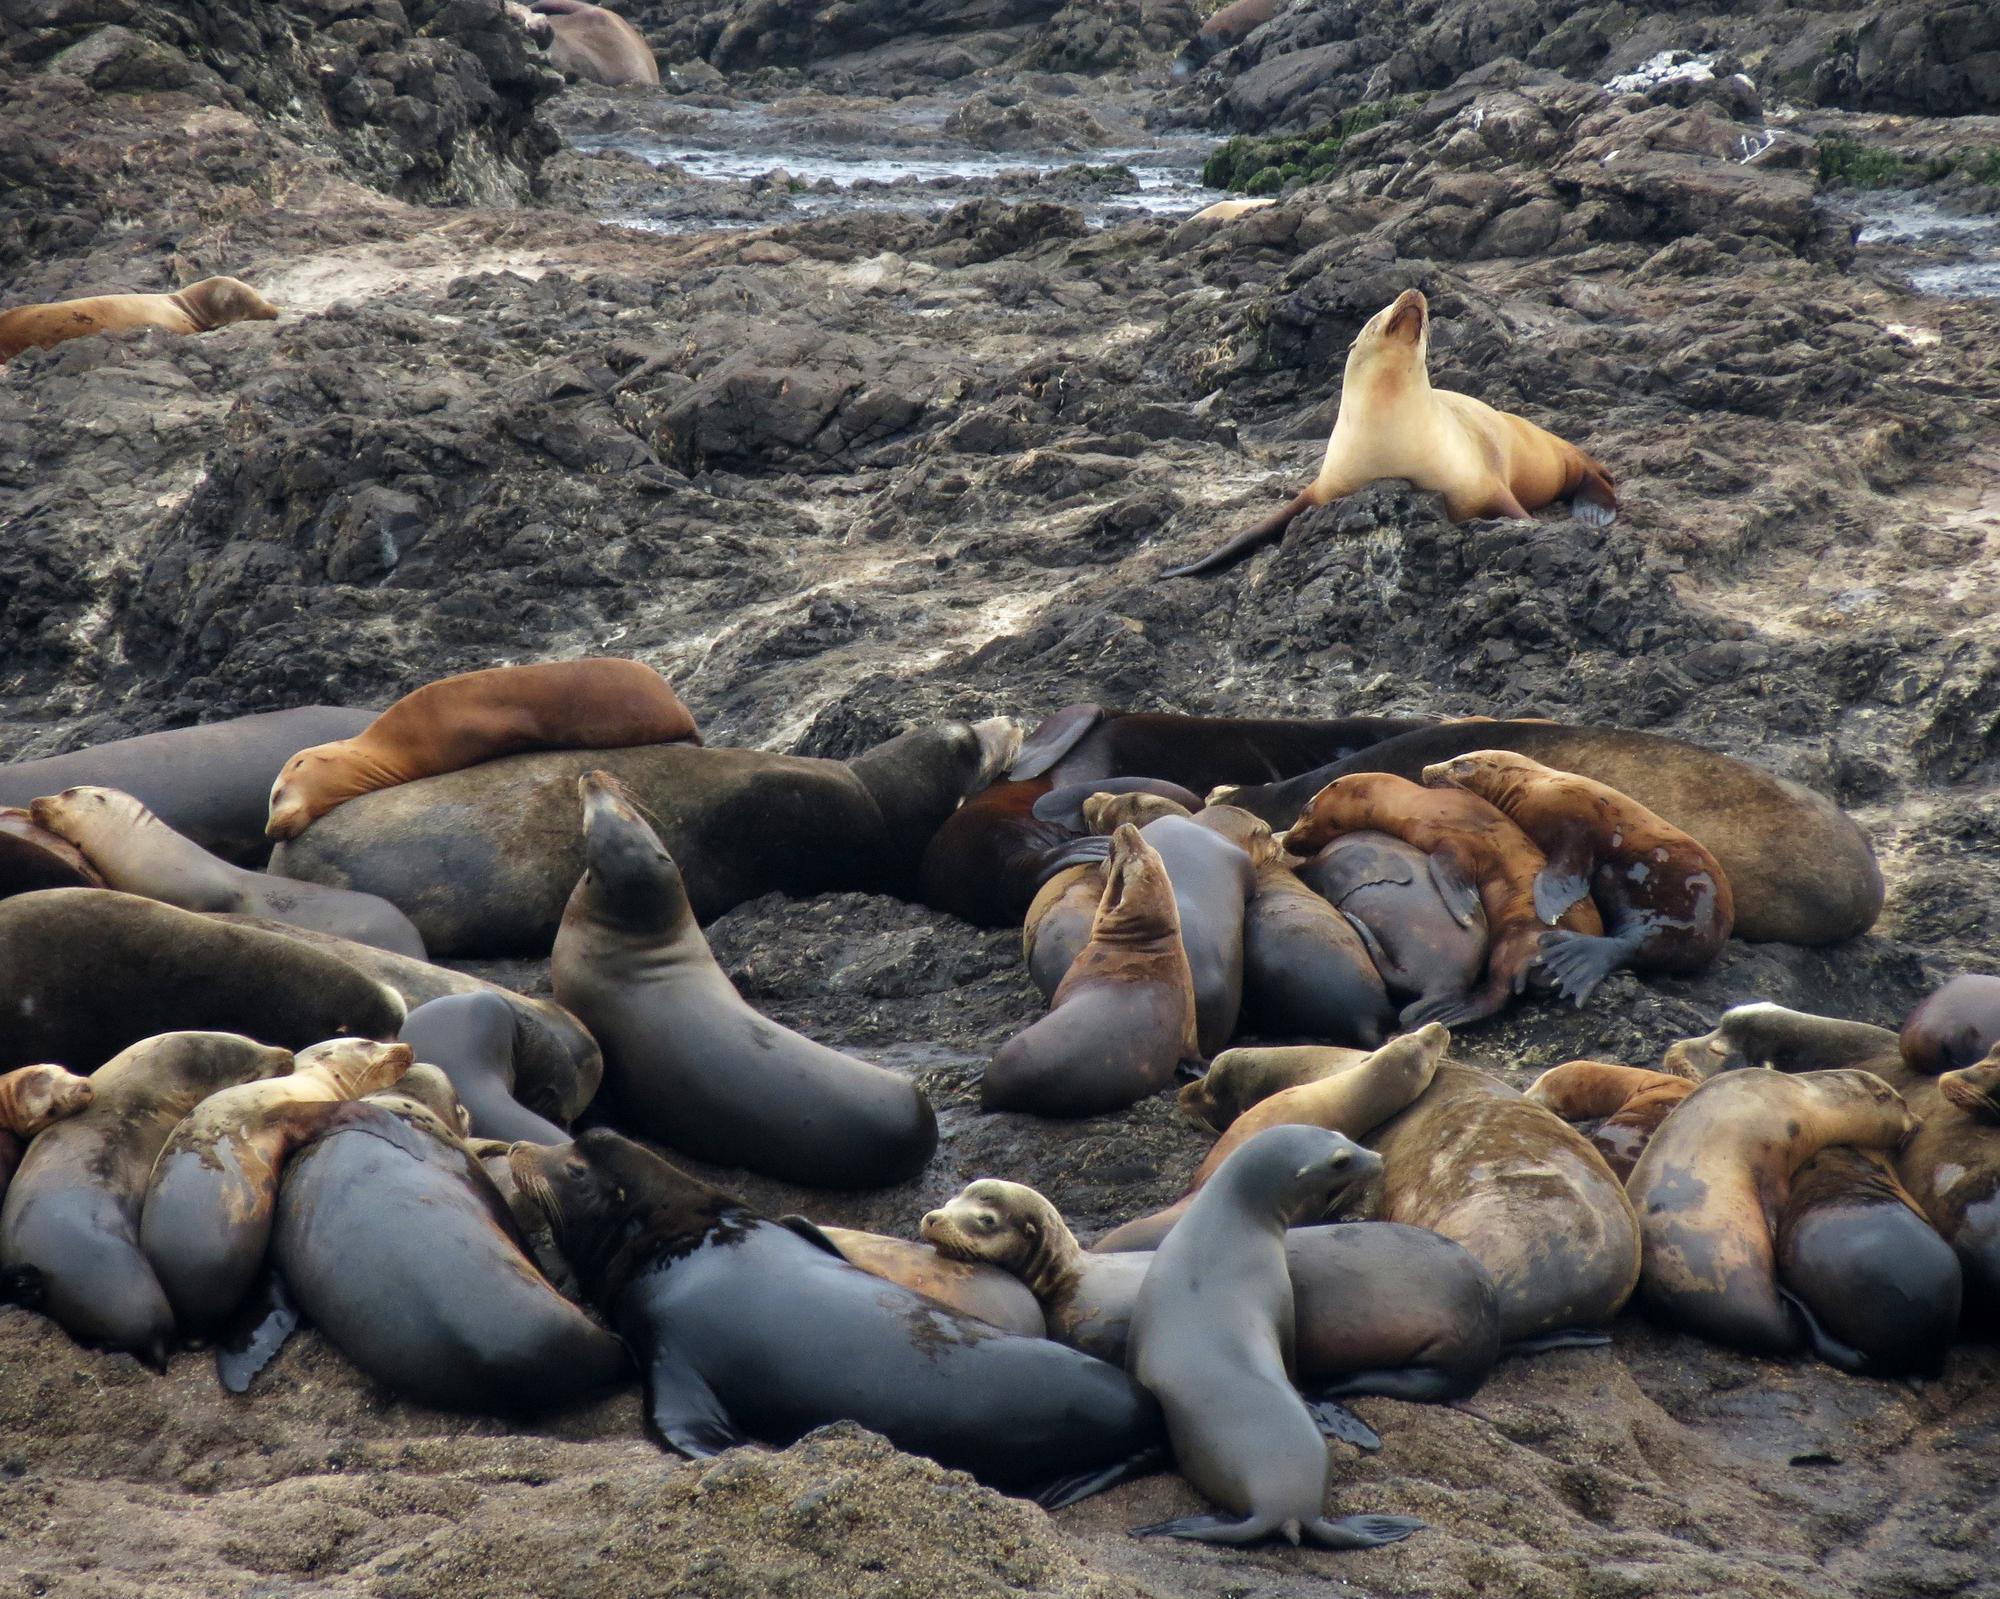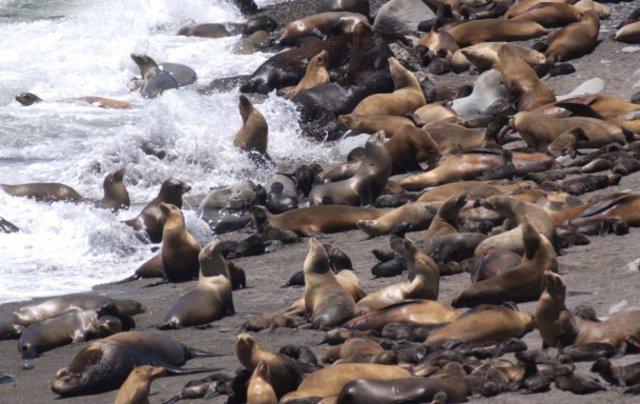The first image is the image on the left, the second image is the image on the right. Examine the images to the left and right. Is the description "There are multiple young pups with adults close to the edge of the water." accurate? Answer yes or no. Yes. The first image is the image on the left, the second image is the image on the right. Analyze the images presented: Is the assertion "One image shows white spray from waves crashing where seals are gathered, and the other shows a mass of seals with no ocean background." valid? Answer yes or no. Yes. 